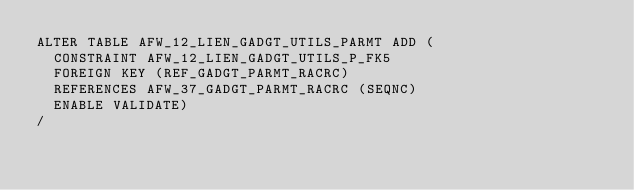<code> <loc_0><loc_0><loc_500><loc_500><_SQL_>ALTER TABLE AFW_12_LIEN_GADGT_UTILS_PARMT ADD (
  CONSTRAINT AFW_12_LIEN_GADGT_UTILS_P_FK5 
  FOREIGN KEY (REF_GADGT_PARMT_RACRC) 
  REFERENCES AFW_37_GADGT_PARMT_RACRC (SEQNC)
  ENABLE VALIDATE)
/
</code> 